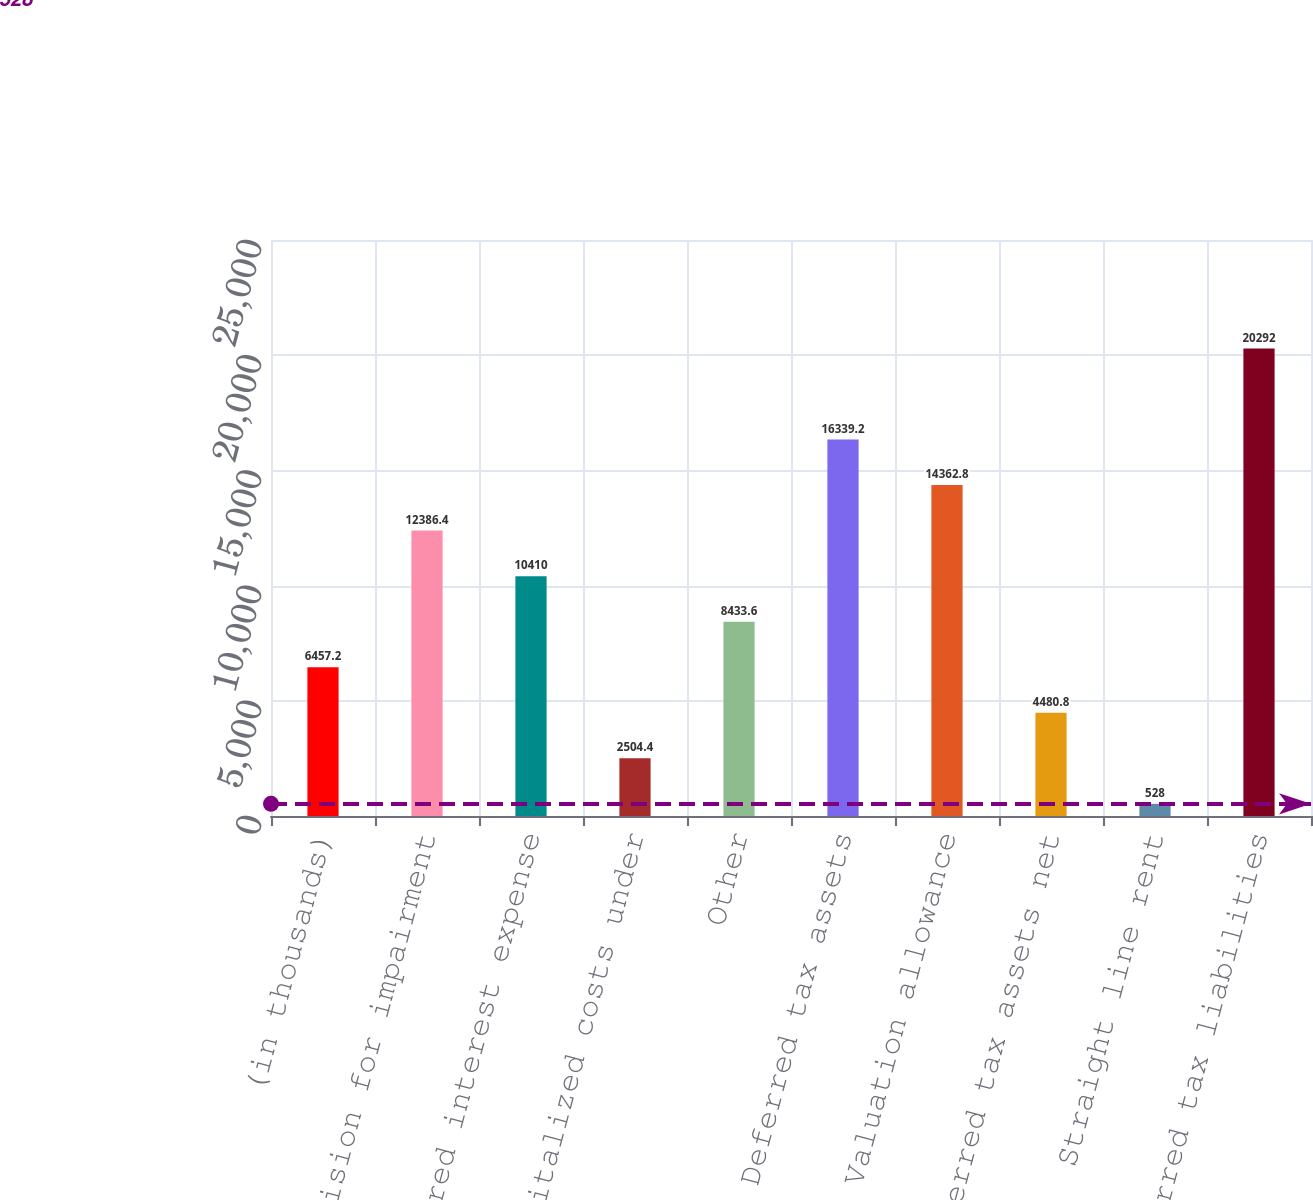Convert chart. <chart><loc_0><loc_0><loc_500><loc_500><bar_chart><fcel>(in thousands)<fcel>Provision for impairment<fcel>Deferred interest expense<fcel>Capitalized costs under<fcel>Other<fcel>Deferred tax assets<fcel>Valuation allowance<fcel>Deferred tax assets net<fcel>Straight line rent<fcel>Deferred tax liabilities<nl><fcel>6457.2<fcel>12386.4<fcel>10410<fcel>2504.4<fcel>8433.6<fcel>16339.2<fcel>14362.8<fcel>4480.8<fcel>528<fcel>20292<nl></chart> 